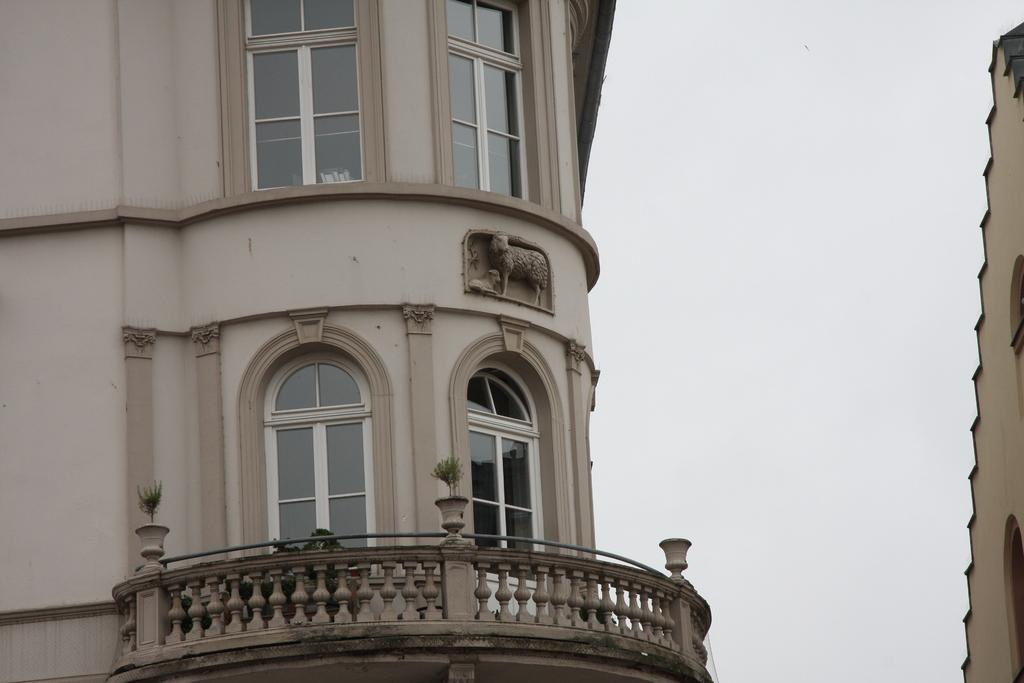What type of building is in the image? There is a white building in the image. What feature can be observed on the building? The building has glass windows. What can be seen on the balcony of the building? There are plants on the balcony of the building. How many wheels are attached to the plants on the balcony? There are no wheels present on the plants or the balcony in the image. 